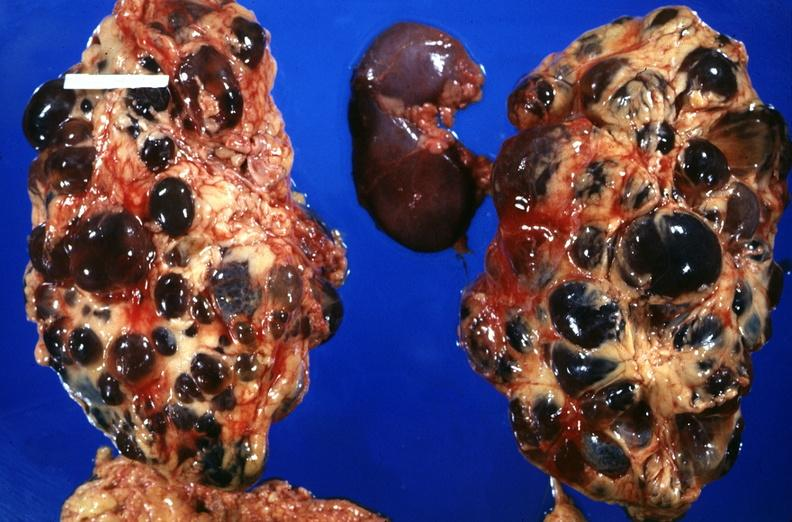does feet show kidney, adult polycystic kidney?
Answer the question using a single word or phrase. No 